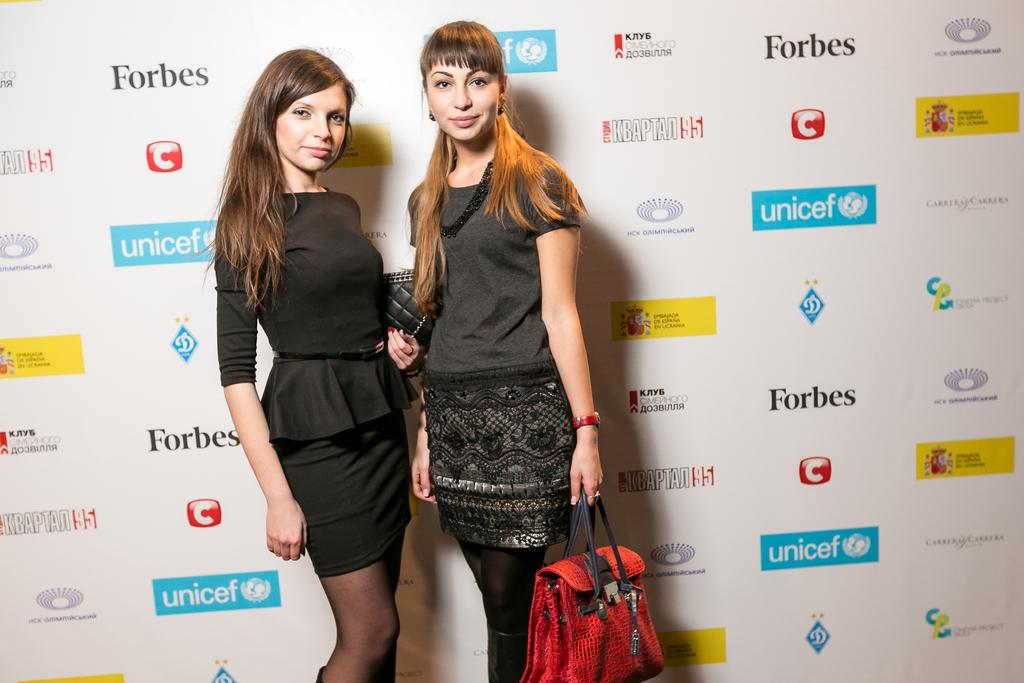How many people are in the image? There are two women in the image. What are the women doing in the image? The women are standing and taking a picture. What are the women holding in the image? The women are holding a bag. What type of bread can be seen in the image? There is no bread present in the image. 